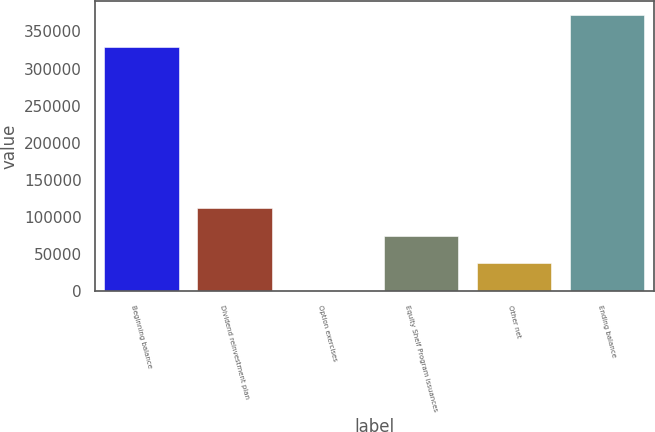Convert chart to OTSL. <chart><loc_0><loc_0><loc_500><loc_500><bar_chart><fcel>Beginning balance<fcel>Dividend reinvestment plan<fcel>Option exercises<fcel>Equity Shelf Program issuances<fcel>Other net<fcel>Ending balance<nl><fcel>328790<fcel>111970<fcel>643<fcel>74860.8<fcel>37751.9<fcel>371732<nl></chart> 